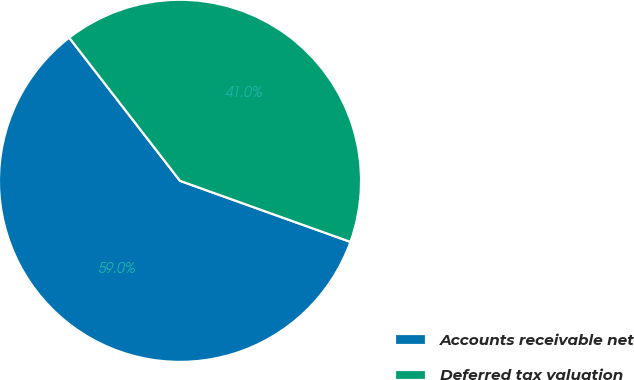<chart> <loc_0><loc_0><loc_500><loc_500><pie_chart><fcel>Accounts receivable net<fcel>Deferred tax valuation<nl><fcel>59.04%<fcel>40.96%<nl></chart> 